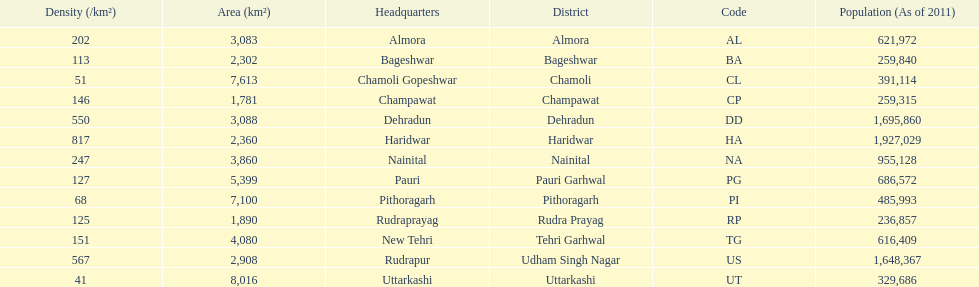How many total districts are there in this area? 13. 